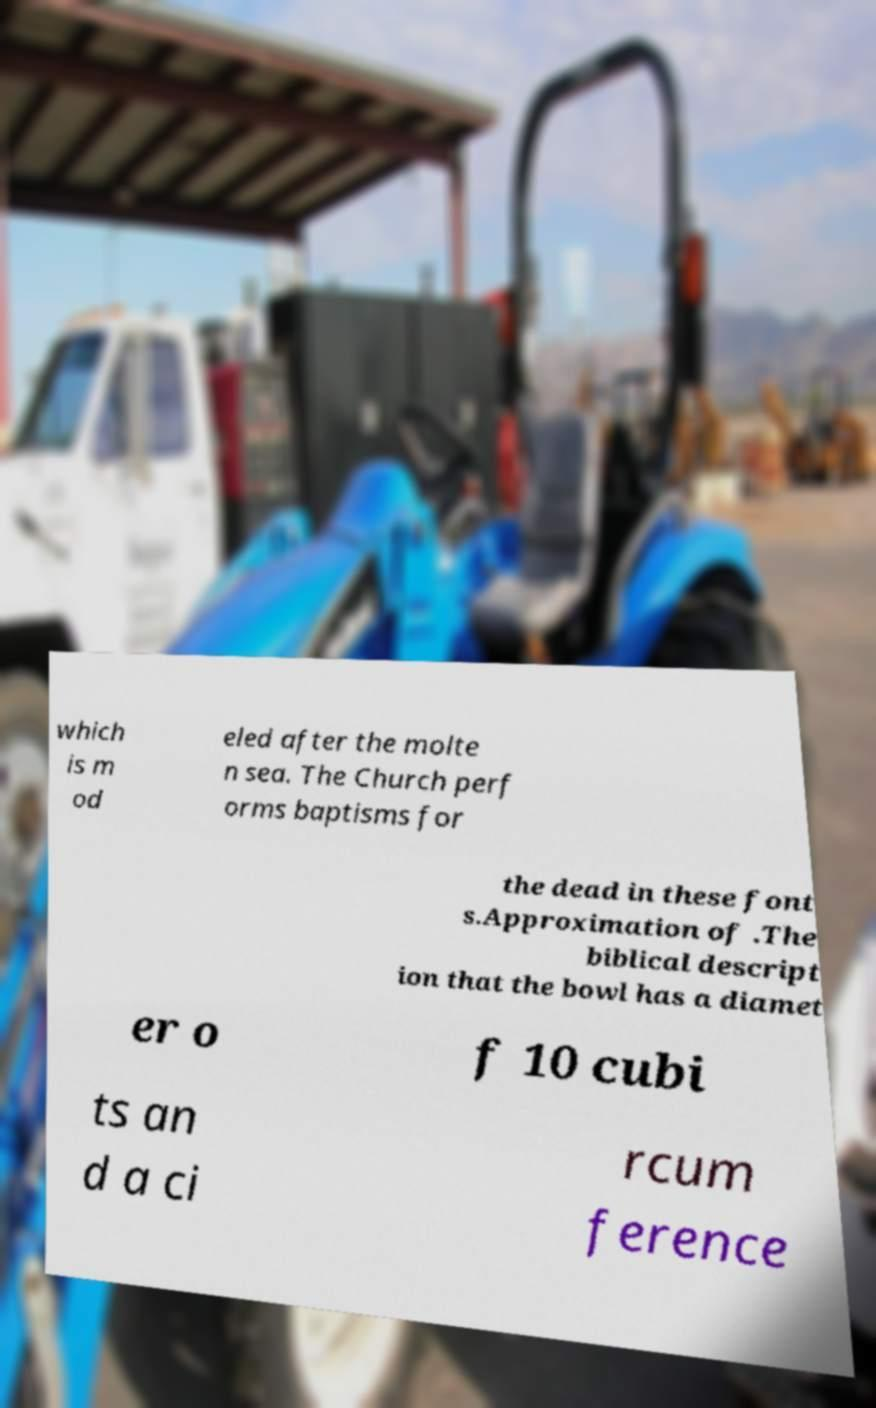There's text embedded in this image that I need extracted. Can you transcribe it verbatim? which is m od eled after the molte n sea. The Church perf orms baptisms for the dead in these font s.Approximation of .The biblical descript ion that the bowl has a diamet er o f 10 cubi ts an d a ci rcum ference 